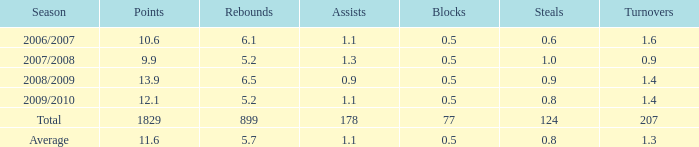9 steals and under None. 